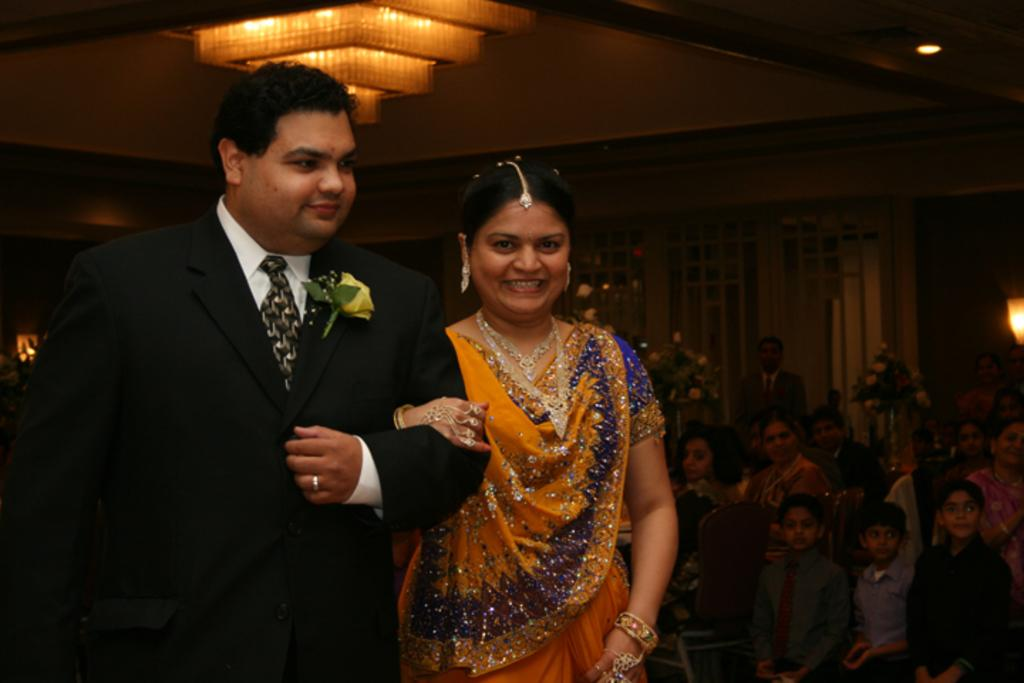What are the man and lady in the image doing? The man and lady in the image are standing and smiling. What can be seen in the background of the image? There are people sitting, lights, doors, and a wall visible in the background of the image. What type of soup is being served in the image? There is no soup present in the image. What is the voice of the man in the image? The image is a still photograph, so there is no sound or voice present. 